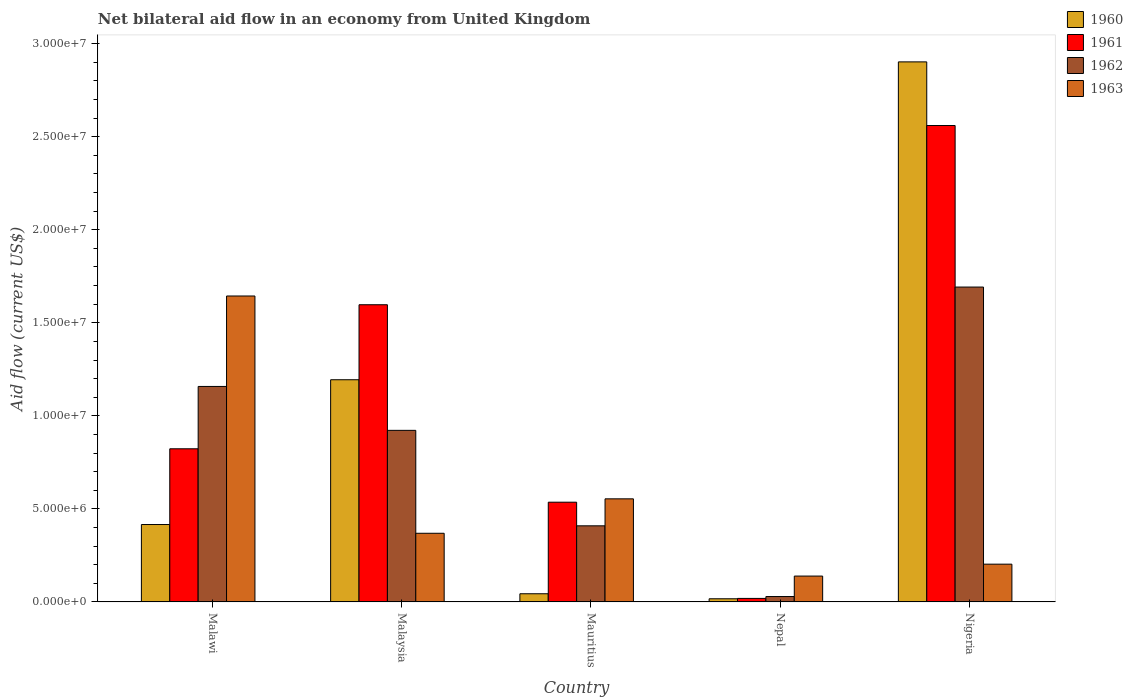How many different coloured bars are there?
Give a very brief answer. 4. How many groups of bars are there?
Give a very brief answer. 5. How many bars are there on the 3rd tick from the right?
Ensure brevity in your answer.  4. What is the label of the 2nd group of bars from the left?
Keep it short and to the point. Malaysia. What is the net bilateral aid flow in 1961 in Mauritius?
Give a very brief answer. 5.36e+06. Across all countries, what is the maximum net bilateral aid flow in 1963?
Keep it short and to the point. 1.64e+07. Across all countries, what is the minimum net bilateral aid flow in 1962?
Offer a terse response. 2.90e+05. In which country was the net bilateral aid flow in 1962 maximum?
Your answer should be compact. Nigeria. In which country was the net bilateral aid flow in 1963 minimum?
Ensure brevity in your answer.  Nepal. What is the total net bilateral aid flow in 1963 in the graph?
Your answer should be very brief. 2.91e+07. What is the difference between the net bilateral aid flow in 1960 in Malaysia and that in Mauritius?
Keep it short and to the point. 1.15e+07. What is the difference between the net bilateral aid flow in 1963 in Malaysia and the net bilateral aid flow in 1960 in Malawi?
Your answer should be very brief. -4.70e+05. What is the average net bilateral aid flow in 1960 per country?
Your answer should be very brief. 9.15e+06. What is the difference between the net bilateral aid flow of/in 1963 and net bilateral aid flow of/in 1962 in Nigeria?
Ensure brevity in your answer.  -1.49e+07. What is the ratio of the net bilateral aid flow in 1961 in Malawi to that in Malaysia?
Give a very brief answer. 0.52. Is the net bilateral aid flow in 1960 in Malawi less than that in Mauritius?
Provide a succinct answer. No. What is the difference between the highest and the second highest net bilateral aid flow in 1961?
Make the answer very short. 1.74e+07. What is the difference between the highest and the lowest net bilateral aid flow in 1960?
Offer a terse response. 2.88e+07. In how many countries, is the net bilateral aid flow in 1960 greater than the average net bilateral aid flow in 1960 taken over all countries?
Offer a terse response. 2. What does the 4th bar from the right in Nepal represents?
Your answer should be very brief. 1960. Are all the bars in the graph horizontal?
Offer a terse response. No. How many countries are there in the graph?
Offer a very short reply. 5. What is the difference between two consecutive major ticks on the Y-axis?
Provide a succinct answer. 5.00e+06. Does the graph contain any zero values?
Make the answer very short. No. Does the graph contain grids?
Provide a short and direct response. No. Where does the legend appear in the graph?
Your answer should be very brief. Top right. How many legend labels are there?
Offer a very short reply. 4. How are the legend labels stacked?
Provide a succinct answer. Vertical. What is the title of the graph?
Ensure brevity in your answer.  Net bilateral aid flow in an economy from United Kingdom. What is the Aid flow (current US$) in 1960 in Malawi?
Offer a terse response. 4.16e+06. What is the Aid flow (current US$) of 1961 in Malawi?
Offer a very short reply. 8.23e+06. What is the Aid flow (current US$) of 1962 in Malawi?
Your answer should be compact. 1.16e+07. What is the Aid flow (current US$) of 1963 in Malawi?
Provide a short and direct response. 1.64e+07. What is the Aid flow (current US$) in 1960 in Malaysia?
Your answer should be compact. 1.19e+07. What is the Aid flow (current US$) in 1961 in Malaysia?
Your answer should be compact. 1.60e+07. What is the Aid flow (current US$) of 1962 in Malaysia?
Provide a succinct answer. 9.22e+06. What is the Aid flow (current US$) in 1963 in Malaysia?
Offer a terse response. 3.69e+06. What is the Aid flow (current US$) of 1960 in Mauritius?
Ensure brevity in your answer.  4.40e+05. What is the Aid flow (current US$) of 1961 in Mauritius?
Offer a very short reply. 5.36e+06. What is the Aid flow (current US$) in 1962 in Mauritius?
Give a very brief answer. 4.09e+06. What is the Aid flow (current US$) in 1963 in Mauritius?
Keep it short and to the point. 5.54e+06. What is the Aid flow (current US$) in 1961 in Nepal?
Your response must be concise. 1.90e+05. What is the Aid flow (current US$) of 1963 in Nepal?
Your answer should be very brief. 1.39e+06. What is the Aid flow (current US$) in 1960 in Nigeria?
Offer a terse response. 2.90e+07. What is the Aid flow (current US$) in 1961 in Nigeria?
Make the answer very short. 2.56e+07. What is the Aid flow (current US$) in 1962 in Nigeria?
Ensure brevity in your answer.  1.69e+07. What is the Aid flow (current US$) of 1963 in Nigeria?
Your answer should be compact. 2.03e+06. Across all countries, what is the maximum Aid flow (current US$) in 1960?
Ensure brevity in your answer.  2.90e+07. Across all countries, what is the maximum Aid flow (current US$) in 1961?
Provide a succinct answer. 2.56e+07. Across all countries, what is the maximum Aid flow (current US$) of 1962?
Your answer should be very brief. 1.69e+07. Across all countries, what is the maximum Aid flow (current US$) in 1963?
Provide a succinct answer. 1.64e+07. Across all countries, what is the minimum Aid flow (current US$) of 1963?
Your answer should be very brief. 1.39e+06. What is the total Aid flow (current US$) in 1960 in the graph?
Your response must be concise. 4.57e+07. What is the total Aid flow (current US$) of 1961 in the graph?
Offer a very short reply. 5.54e+07. What is the total Aid flow (current US$) in 1962 in the graph?
Provide a short and direct response. 4.21e+07. What is the total Aid flow (current US$) in 1963 in the graph?
Your answer should be compact. 2.91e+07. What is the difference between the Aid flow (current US$) of 1960 in Malawi and that in Malaysia?
Give a very brief answer. -7.78e+06. What is the difference between the Aid flow (current US$) of 1961 in Malawi and that in Malaysia?
Provide a succinct answer. -7.74e+06. What is the difference between the Aid flow (current US$) in 1962 in Malawi and that in Malaysia?
Provide a succinct answer. 2.36e+06. What is the difference between the Aid flow (current US$) in 1963 in Malawi and that in Malaysia?
Ensure brevity in your answer.  1.28e+07. What is the difference between the Aid flow (current US$) in 1960 in Malawi and that in Mauritius?
Your answer should be compact. 3.72e+06. What is the difference between the Aid flow (current US$) of 1961 in Malawi and that in Mauritius?
Provide a short and direct response. 2.87e+06. What is the difference between the Aid flow (current US$) of 1962 in Malawi and that in Mauritius?
Make the answer very short. 7.49e+06. What is the difference between the Aid flow (current US$) of 1963 in Malawi and that in Mauritius?
Ensure brevity in your answer.  1.09e+07. What is the difference between the Aid flow (current US$) of 1960 in Malawi and that in Nepal?
Offer a terse response. 3.99e+06. What is the difference between the Aid flow (current US$) in 1961 in Malawi and that in Nepal?
Your answer should be compact. 8.04e+06. What is the difference between the Aid flow (current US$) of 1962 in Malawi and that in Nepal?
Your response must be concise. 1.13e+07. What is the difference between the Aid flow (current US$) of 1963 in Malawi and that in Nepal?
Ensure brevity in your answer.  1.50e+07. What is the difference between the Aid flow (current US$) of 1960 in Malawi and that in Nigeria?
Provide a short and direct response. -2.49e+07. What is the difference between the Aid flow (current US$) in 1961 in Malawi and that in Nigeria?
Ensure brevity in your answer.  -1.74e+07. What is the difference between the Aid flow (current US$) of 1962 in Malawi and that in Nigeria?
Provide a short and direct response. -5.34e+06. What is the difference between the Aid flow (current US$) of 1963 in Malawi and that in Nigeria?
Give a very brief answer. 1.44e+07. What is the difference between the Aid flow (current US$) of 1960 in Malaysia and that in Mauritius?
Your response must be concise. 1.15e+07. What is the difference between the Aid flow (current US$) of 1961 in Malaysia and that in Mauritius?
Make the answer very short. 1.06e+07. What is the difference between the Aid flow (current US$) in 1962 in Malaysia and that in Mauritius?
Keep it short and to the point. 5.13e+06. What is the difference between the Aid flow (current US$) in 1963 in Malaysia and that in Mauritius?
Provide a succinct answer. -1.85e+06. What is the difference between the Aid flow (current US$) in 1960 in Malaysia and that in Nepal?
Give a very brief answer. 1.18e+07. What is the difference between the Aid flow (current US$) in 1961 in Malaysia and that in Nepal?
Provide a succinct answer. 1.58e+07. What is the difference between the Aid flow (current US$) of 1962 in Malaysia and that in Nepal?
Give a very brief answer. 8.93e+06. What is the difference between the Aid flow (current US$) of 1963 in Malaysia and that in Nepal?
Your response must be concise. 2.30e+06. What is the difference between the Aid flow (current US$) of 1960 in Malaysia and that in Nigeria?
Keep it short and to the point. -1.71e+07. What is the difference between the Aid flow (current US$) in 1961 in Malaysia and that in Nigeria?
Provide a succinct answer. -9.63e+06. What is the difference between the Aid flow (current US$) in 1962 in Malaysia and that in Nigeria?
Offer a terse response. -7.70e+06. What is the difference between the Aid flow (current US$) in 1963 in Malaysia and that in Nigeria?
Your response must be concise. 1.66e+06. What is the difference between the Aid flow (current US$) of 1960 in Mauritius and that in Nepal?
Ensure brevity in your answer.  2.70e+05. What is the difference between the Aid flow (current US$) of 1961 in Mauritius and that in Nepal?
Provide a short and direct response. 5.17e+06. What is the difference between the Aid flow (current US$) of 1962 in Mauritius and that in Nepal?
Your answer should be compact. 3.80e+06. What is the difference between the Aid flow (current US$) of 1963 in Mauritius and that in Nepal?
Your answer should be very brief. 4.15e+06. What is the difference between the Aid flow (current US$) in 1960 in Mauritius and that in Nigeria?
Keep it short and to the point. -2.86e+07. What is the difference between the Aid flow (current US$) in 1961 in Mauritius and that in Nigeria?
Your answer should be compact. -2.02e+07. What is the difference between the Aid flow (current US$) in 1962 in Mauritius and that in Nigeria?
Ensure brevity in your answer.  -1.28e+07. What is the difference between the Aid flow (current US$) in 1963 in Mauritius and that in Nigeria?
Keep it short and to the point. 3.51e+06. What is the difference between the Aid flow (current US$) of 1960 in Nepal and that in Nigeria?
Your response must be concise. -2.88e+07. What is the difference between the Aid flow (current US$) of 1961 in Nepal and that in Nigeria?
Your answer should be compact. -2.54e+07. What is the difference between the Aid flow (current US$) of 1962 in Nepal and that in Nigeria?
Ensure brevity in your answer.  -1.66e+07. What is the difference between the Aid flow (current US$) in 1963 in Nepal and that in Nigeria?
Make the answer very short. -6.40e+05. What is the difference between the Aid flow (current US$) of 1960 in Malawi and the Aid flow (current US$) of 1961 in Malaysia?
Your answer should be very brief. -1.18e+07. What is the difference between the Aid flow (current US$) of 1960 in Malawi and the Aid flow (current US$) of 1962 in Malaysia?
Your answer should be compact. -5.06e+06. What is the difference between the Aid flow (current US$) in 1961 in Malawi and the Aid flow (current US$) in 1962 in Malaysia?
Offer a terse response. -9.90e+05. What is the difference between the Aid flow (current US$) in 1961 in Malawi and the Aid flow (current US$) in 1963 in Malaysia?
Offer a very short reply. 4.54e+06. What is the difference between the Aid flow (current US$) of 1962 in Malawi and the Aid flow (current US$) of 1963 in Malaysia?
Provide a succinct answer. 7.89e+06. What is the difference between the Aid flow (current US$) in 1960 in Malawi and the Aid flow (current US$) in 1961 in Mauritius?
Give a very brief answer. -1.20e+06. What is the difference between the Aid flow (current US$) of 1960 in Malawi and the Aid flow (current US$) of 1963 in Mauritius?
Ensure brevity in your answer.  -1.38e+06. What is the difference between the Aid flow (current US$) in 1961 in Malawi and the Aid flow (current US$) in 1962 in Mauritius?
Give a very brief answer. 4.14e+06. What is the difference between the Aid flow (current US$) of 1961 in Malawi and the Aid flow (current US$) of 1963 in Mauritius?
Your response must be concise. 2.69e+06. What is the difference between the Aid flow (current US$) in 1962 in Malawi and the Aid flow (current US$) in 1963 in Mauritius?
Offer a very short reply. 6.04e+06. What is the difference between the Aid flow (current US$) in 1960 in Malawi and the Aid flow (current US$) in 1961 in Nepal?
Offer a very short reply. 3.97e+06. What is the difference between the Aid flow (current US$) in 1960 in Malawi and the Aid flow (current US$) in 1962 in Nepal?
Offer a very short reply. 3.87e+06. What is the difference between the Aid flow (current US$) of 1960 in Malawi and the Aid flow (current US$) of 1963 in Nepal?
Make the answer very short. 2.77e+06. What is the difference between the Aid flow (current US$) in 1961 in Malawi and the Aid flow (current US$) in 1962 in Nepal?
Offer a very short reply. 7.94e+06. What is the difference between the Aid flow (current US$) in 1961 in Malawi and the Aid flow (current US$) in 1963 in Nepal?
Your answer should be very brief. 6.84e+06. What is the difference between the Aid flow (current US$) of 1962 in Malawi and the Aid flow (current US$) of 1963 in Nepal?
Make the answer very short. 1.02e+07. What is the difference between the Aid flow (current US$) of 1960 in Malawi and the Aid flow (current US$) of 1961 in Nigeria?
Keep it short and to the point. -2.14e+07. What is the difference between the Aid flow (current US$) in 1960 in Malawi and the Aid flow (current US$) in 1962 in Nigeria?
Provide a short and direct response. -1.28e+07. What is the difference between the Aid flow (current US$) of 1960 in Malawi and the Aid flow (current US$) of 1963 in Nigeria?
Ensure brevity in your answer.  2.13e+06. What is the difference between the Aid flow (current US$) in 1961 in Malawi and the Aid flow (current US$) in 1962 in Nigeria?
Offer a terse response. -8.69e+06. What is the difference between the Aid flow (current US$) in 1961 in Malawi and the Aid flow (current US$) in 1963 in Nigeria?
Provide a succinct answer. 6.20e+06. What is the difference between the Aid flow (current US$) in 1962 in Malawi and the Aid flow (current US$) in 1963 in Nigeria?
Your answer should be very brief. 9.55e+06. What is the difference between the Aid flow (current US$) of 1960 in Malaysia and the Aid flow (current US$) of 1961 in Mauritius?
Offer a terse response. 6.58e+06. What is the difference between the Aid flow (current US$) of 1960 in Malaysia and the Aid flow (current US$) of 1962 in Mauritius?
Your response must be concise. 7.85e+06. What is the difference between the Aid flow (current US$) of 1960 in Malaysia and the Aid flow (current US$) of 1963 in Mauritius?
Provide a succinct answer. 6.40e+06. What is the difference between the Aid flow (current US$) in 1961 in Malaysia and the Aid flow (current US$) in 1962 in Mauritius?
Keep it short and to the point. 1.19e+07. What is the difference between the Aid flow (current US$) in 1961 in Malaysia and the Aid flow (current US$) in 1963 in Mauritius?
Provide a succinct answer. 1.04e+07. What is the difference between the Aid flow (current US$) in 1962 in Malaysia and the Aid flow (current US$) in 1963 in Mauritius?
Provide a succinct answer. 3.68e+06. What is the difference between the Aid flow (current US$) of 1960 in Malaysia and the Aid flow (current US$) of 1961 in Nepal?
Make the answer very short. 1.18e+07. What is the difference between the Aid flow (current US$) in 1960 in Malaysia and the Aid flow (current US$) in 1962 in Nepal?
Make the answer very short. 1.16e+07. What is the difference between the Aid flow (current US$) of 1960 in Malaysia and the Aid flow (current US$) of 1963 in Nepal?
Offer a terse response. 1.06e+07. What is the difference between the Aid flow (current US$) of 1961 in Malaysia and the Aid flow (current US$) of 1962 in Nepal?
Your response must be concise. 1.57e+07. What is the difference between the Aid flow (current US$) in 1961 in Malaysia and the Aid flow (current US$) in 1963 in Nepal?
Offer a very short reply. 1.46e+07. What is the difference between the Aid flow (current US$) of 1962 in Malaysia and the Aid flow (current US$) of 1963 in Nepal?
Provide a short and direct response. 7.83e+06. What is the difference between the Aid flow (current US$) of 1960 in Malaysia and the Aid flow (current US$) of 1961 in Nigeria?
Provide a short and direct response. -1.37e+07. What is the difference between the Aid flow (current US$) of 1960 in Malaysia and the Aid flow (current US$) of 1962 in Nigeria?
Your answer should be compact. -4.98e+06. What is the difference between the Aid flow (current US$) of 1960 in Malaysia and the Aid flow (current US$) of 1963 in Nigeria?
Provide a short and direct response. 9.91e+06. What is the difference between the Aid flow (current US$) in 1961 in Malaysia and the Aid flow (current US$) in 1962 in Nigeria?
Offer a terse response. -9.50e+05. What is the difference between the Aid flow (current US$) of 1961 in Malaysia and the Aid flow (current US$) of 1963 in Nigeria?
Give a very brief answer. 1.39e+07. What is the difference between the Aid flow (current US$) of 1962 in Malaysia and the Aid flow (current US$) of 1963 in Nigeria?
Your response must be concise. 7.19e+06. What is the difference between the Aid flow (current US$) in 1960 in Mauritius and the Aid flow (current US$) in 1961 in Nepal?
Provide a succinct answer. 2.50e+05. What is the difference between the Aid flow (current US$) in 1960 in Mauritius and the Aid flow (current US$) in 1963 in Nepal?
Provide a succinct answer. -9.50e+05. What is the difference between the Aid flow (current US$) in 1961 in Mauritius and the Aid flow (current US$) in 1962 in Nepal?
Make the answer very short. 5.07e+06. What is the difference between the Aid flow (current US$) in 1961 in Mauritius and the Aid flow (current US$) in 1963 in Nepal?
Ensure brevity in your answer.  3.97e+06. What is the difference between the Aid flow (current US$) of 1962 in Mauritius and the Aid flow (current US$) of 1963 in Nepal?
Offer a very short reply. 2.70e+06. What is the difference between the Aid flow (current US$) of 1960 in Mauritius and the Aid flow (current US$) of 1961 in Nigeria?
Provide a short and direct response. -2.52e+07. What is the difference between the Aid flow (current US$) of 1960 in Mauritius and the Aid flow (current US$) of 1962 in Nigeria?
Your answer should be compact. -1.65e+07. What is the difference between the Aid flow (current US$) in 1960 in Mauritius and the Aid flow (current US$) in 1963 in Nigeria?
Ensure brevity in your answer.  -1.59e+06. What is the difference between the Aid flow (current US$) of 1961 in Mauritius and the Aid flow (current US$) of 1962 in Nigeria?
Your response must be concise. -1.16e+07. What is the difference between the Aid flow (current US$) of 1961 in Mauritius and the Aid flow (current US$) of 1963 in Nigeria?
Your answer should be compact. 3.33e+06. What is the difference between the Aid flow (current US$) of 1962 in Mauritius and the Aid flow (current US$) of 1963 in Nigeria?
Offer a very short reply. 2.06e+06. What is the difference between the Aid flow (current US$) of 1960 in Nepal and the Aid flow (current US$) of 1961 in Nigeria?
Offer a very short reply. -2.54e+07. What is the difference between the Aid flow (current US$) in 1960 in Nepal and the Aid flow (current US$) in 1962 in Nigeria?
Give a very brief answer. -1.68e+07. What is the difference between the Aid flow (current US$) of 1960 in Nepal and the Aid flow (current US$) of 1963 in Nigeria?
Your response must be concise. -1.86e+06. What is the difference between the Aid flow (current US$) in 1961 in Nepal and the Aid flow (current US$) in 1962 in Nigeria?
Your response must be concise. -1.67e+07. What is the difference between the Aid flow (current US$) in 1961 in Nepal and the Aid flow (current US$) in 1963 in Nigeria?
Ensure brevity in your answer.  -1.84e+06. What is the difference between the Aid flow (current US$) of 1962 in Nepal and the Aid flow (current US$) of 1963 in Nigeria?
Your answer should be very brief. -1.74e+06. What is the average Aid flow (current US$) in 1960 per country?
Your answer should be compact. 9.15e+06. What is the average Aid flow (current US$) in 1961 per country?
Make the answer very short. 1.11e+07. What is the average Aid flow (current US$) of 1962 per country?
Give a very brief answer. 8.42e+06. What is the average Aid flow (current US$) of 1963 per country?
Your answer should be compact. 5.82e+06. What is the difference between the Aid flow (current US$) of 1960 and Aid flow (current US$) of 1961 in Malawi?
Provide a succinct answer. -4.07e+06. What is the difference between the Aid flow (current US$) of 1960 and Aid flow (current US$) of 1962 in Malawi?
Give a very brief answer. -7.42e+06. What is the difference between the Aid flow (current US$) in 1960 and Aid flow (current US$) in 1963 in Malawi?
Keep it short and to the point. -1.23e+07. What is the difference between the Aid flow (current US$) of 1961 and Aid flow (current US$) of 1962 in Malawi?
Make the answer very short. -3.35e+06. What is the difference between the Aid flow (current US$) of 1961 and Aid flow (current US$) of 1963 in Malawi?
Offer a very short reply. -8.21e+06. What is the difference between the Aid flow (current US$) of 1962 and Aid flow (current US$) of 1963 in Malawi?
Provide a short and direct response. -4.86e+06. What is the difference between the Aid flow (current US$) in 1960 and Aid flow (current US$) in 1961 in Malaysia?
Your answer should be very brief. -4.03e+06. What is the difference between the Aid flow (current US$) of 1960 and Aid flow (current US$) of 1962 in Malaysia?
Make the answer very short. 2.72e+06. What is the difference between the Aid flow (current US$) in 1960 and Aid flow (current US$) in 1963 in Malaysia?
Make the answer very short. 8.25e+06. What is the difference between the Aid flow (current US$) in 1961 and Aid flow (current US$) in 1962 in Malaysia?
Ensure brevity in your answer.  6.75e+06. What is the difference between the Aid flow (current US$) in 1961 and Aid flow (current US$) in 1963 in Malaysia?
Offer a terse response. 1.23e+07. What is the difference between the Aid flow (current US$) of 1962 and Aid flow (current US$) of 1963 in Malaysia?
Keep it short and to the point. 5.53e+06. What is the difference between the Aid flow (current US$) in 1960 and Aid flow (current US$) in 1961 in Mauritius?
Your answer should be very brief. -4.92e+06. What is the difference between the Aid flow (current US$) of 1960 and Aid flow (current US$) of 1962 in Mauritius?
Give a very brief answer. -3.65e+06. What is the difference between the Aid flow (current US$) in 1960 and Aid flow (current US$) in 1963 in Mauritius?
Offer a terse response. -5.10e+06. What is the difference between the Aid flow (current US$) in 1961 and Aid flow (current US$) in 1962 in Mauritius?
Give a very brief answer. 1.27e+06. What is the difference between the Aid flow (current US$) in 1961 and Aid flow (current US$) in 1963 in Mauritius?
Provide a short and direct response. -1.80e+05. What is the difference between the Aid flow (current US$) of 1962 and Aid flow (current US$) of 1963 in Mauritius?
Your answer should be very brief. -1.45e+06. What is the difference between the Aid flow (current US$) of 1960 and Aid flow (current US$) of 1961 in Nepal?
Offer a very short reply. -2.00e+04. What is the difference between the Aid flow (current US$) in 1960 and Aid flow (current US$) in 1962 in Nepal?
Offer a very short reply. -1.20e+05. What is the difference between the Aid flow (current US$) of 1960 and Aid flow (current US$) of 1963 in Nepal?
Offer a terse response. -1.22e+06. What is the difference between the Aid flow (current US$) of 1961 and Aid flow (current US$) of 1963 in Nepal?
Ensure brevity in your answer.  -1.20e+06. What is the difference between the Aid flow (current US$) in 1962 and Aid flow (current US$) in 1963 in Nepal?
Offer a terse response. -1.10e+06. What is the difference between the Aid flow (current US$) in 1960 and Aid flow (current US$) in 1961 in Nigeria?
Ensure brevity in your answer.  3.42e+06. What is the difference between the Aid flow (current US$) of 1960 and Aid flow (current US$) of 1962 in Nigeria?
Give a very brief answer. 1.21e+07. What is the difference between the Aid flow (current US$) in 1960 and Aid flow (current US$) in 1963 in Nigeria?
Your answer should be very brief. 2.70e+07. What is the difference between the Aid flow (current US$) in 1961 and Aid flow (current US$) in 1962 in Nigeria?
Keep it short and to the point. 8.68e+06. What is the difference between the Aid flow (current US$) of 1961 and Aid flow (current US$) of 1963 in Nigeria?
Ensure brevity in your answer.  2.36e+07. What is the difference between the Aid flow (current US$) in 1962 and Aid flow (current US$) in 1963 in Nigeria?
Offer a terse response. 1.49e+07. What is the ratio of the Aid flow (current US$) of 1960 in Malawi to that in Malaysia?
Offer a very short reply. 0.35. What is the ratio of the Aid flow (current US$) of 1961 in Malawi to that in Malaysia?
Offer a very short reply. 0.52. What is the ratio of the Aid flow (current US$) in 1962 in Malawi to that in Malaysia?
Offer a very short reply. 1.26. What is the ratio of the Aid flow (current US$) of 1963 in Malawi to that in Malaysia?
Provide a succinct answer. 4.46. What is the ratio of the Aid flow (current US$) of 1960 in Malawi to that in Mauritius?
Your answer should be compact. 9.45. What is the ratio of the Aid flow (current US$) of 1961 in Malawi to that in Mauritius?
Provide a succinct answer. 1.54. What is the ratio of the Aid flow (current US$) in 1962 in Malawi to that in Mauritius?
Make the answer very short. 2.83. What is the ratio of the Aid flow (current US$) in 1963 in Malawi to that in Mauritius?
Your response must be concise. 2.97. What is the ratio of the Aid flow (current US$) of 1960 in Malawi to that in Nepal?
Your answer should be very brief. 24.47. What is the ratio of the Aid flow (current US$) in 1961 in Malawi to that in Nepal?
Offer a terse response. 43.32. What is the ratio of the Aid flow (current US$) in 1962 in Malawi to that in Nepal?
Your answer should be very brief. 39.93. What is the ratio of the Aid flow (current US$) of 1963 in Malawi to that in Nepal?
Give a very brief answer. 11.83. What is the ratio of the Aid flow (current US$) of 1960 in Malawi to that in Nigeria?
Offer a very short reply. 0.14. What is the ratio of the Aid flow (current US$) of 1961 in Malawi to that in Nigeria?
Offer a very short reply. 0.32. What is the ratio of the Aid flow (current US$) in 1962 in Malawi to that in Nigeria?
Offer a terse response. 0.68. What is the ratio of the Aid flow (current US$) in 1963 in Malawi to that in Nigeria?
Your response must be concise. 8.1. What is the ratio of the Aid flow (current US$) in 1960 in Malaysia to that in Mauritius?
Your answer should be very brief. 27.14. What is the ratio of the Aid flow (current US$) in 1961 in Malaysia to that in Mauritius?
Make the answer very short. 2.98. What is the ratio of the Aid flow (current US$) in 1962 in Malaysia to that in Mauritius?
Keep it short and to the point. 2.25. What is the ratio of the Aid flow (current US$) in 1963 in Malaysia to that in Mauritius?
Make the answer very short. 0.67. What is the ratio of the Aid flow (current US$) in 1960 in Malaysia to that in Nepal?
Provide a succinct answer. 70.24. What is the ratio of the Aid flow (current US$) in 1961 in Malaysia to that in Nepal?
Give a very brief answer. 84.05. What is the ratio of the Aid flow (current US$) of 1962 in Malaysia to that in Nepal?
Your response must be concise. 31.79. What is the ratio of the Aid flow (current US$) in 1963 in Malaysia to that in Nepal?
Give a very brief answer. 2.65. What is the ratio of the Aid flow (current US$) of 1960 in Malaysia to that in Nigeria?
Give a very brief answer. 0.41. What is the ratio of the Aid flow (current US$) of 1961 in Malaysia to that in Nigeria?
Give a very brief answer. 0.62. What is the ratio of the Aid flow (current US$) of 1962 in Malaysia to that in Nigeria?
Provide a short and direct response. 0.54. What is the ratio of the Aid flow (current US$) in 1963 in Malaysia to that in Nigeria?
Offer a very short reply. 1.82. What is the ratio of the Aid flow (current US$) of 1960 in Mauritius to that in Nepal?
Offer a terse response. 2.59. What is the ratio of the Aid flow (current US$) in 1961 in Mauritius to that in Nepal?
Your answer should be very brief. 28.21. What is the ratio of the Aid flow (current US$) of 1962 in Mauritius to that in Nepal?
Offer a terse response. 14.1. What is the ratio of the Aid flow (current US$) of 1963 in Mauritius to that in Nepal?
Ensure brevity in your answer.  3.99. What is the ratio of the Aid flow (current US$) in 1960 in Mauritius to that in Nigeria?
Provide a short and direct response. 0.02. What is the ratio of the Aid flow (current US$) in 1961 in Mauritius to that in Nigeria?
Give a very brief answer. 0.21. What is the ratio of the Aid flow (current US$) in 1962 in Mauritius to that in Nigeria?
Keep it short and to the point. 0.24. What is the ratio of the Aid flow (current US$) of 1963 in Mauritius to that in Nigeria?
Give a very brief answer. 2.73. What is the ratio of the Aid flow (current US$) in 1960 in Nepal to that in Nigeria?
Offer a terse response. 0.01. What is the ratio of the Aid flow (current US$) of 1961 in Nepal to that in Nigeria?
Your answer should be compact. 0.01. What is the ratio of the Aid flow (current US$) in 1962 in Nepal to that in Nigeria?
Your answer should be very brief. 0.02. What is the ratio of the Aid flow (current US$) in 1963 in Nepal to that in Nigeria?
Offer a terse response. 0.68. What is the difference between the highest and the second highest Aid flow (current US$) of 1960?
Offer a terse response. 1.71e+07. What is the difference between the highest and the second highest Aid flow (current US$) of 1961?
Give a very brief answer. 9.63e+06. What is the difference between the highest and the second highest Aid flow (current US$) of 1962?
Ensure brevity in your answer.  5.34e+06. What is the difference between the highest and the second highest Aid flow (current US$) of 1963?
Provide a short and direct response. 1.09e+07. What is the difference between the highest and the lowest Aid flow (current US$) of 1960?
Make the answer very short. 2.88e+07. What is the difference between the highest and the lowest Aid flow (current US$) of 1961?
Offer a very short reply. 2.54e+07. What is the difference between the highest and the lowest Aid flow (current US$) of 1962?
Ensure brevity in your answer.  1.66e+07. What is the difference between the highest and the lowest Aid flow (current US$) of 1963?
Offer a terse response. 1.50e+07. 